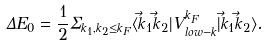Convert formula to latex. <formula><loc_0><loc_0><loc_500><loc_500>\Delta E _ { 0 } = \frac { 1 } { 2 } \Sigma _ { k _ { 1 } , k _ { 2 } \leq k _ { F } } \langle \vec { k } _ { 1 } \vec { k } _ { 2 } | V _ { l o w - k } ^ { k _ { F } } | \vec { k } _ { 1 } \vec { k } _ { 2 } \rangle .</formula> 